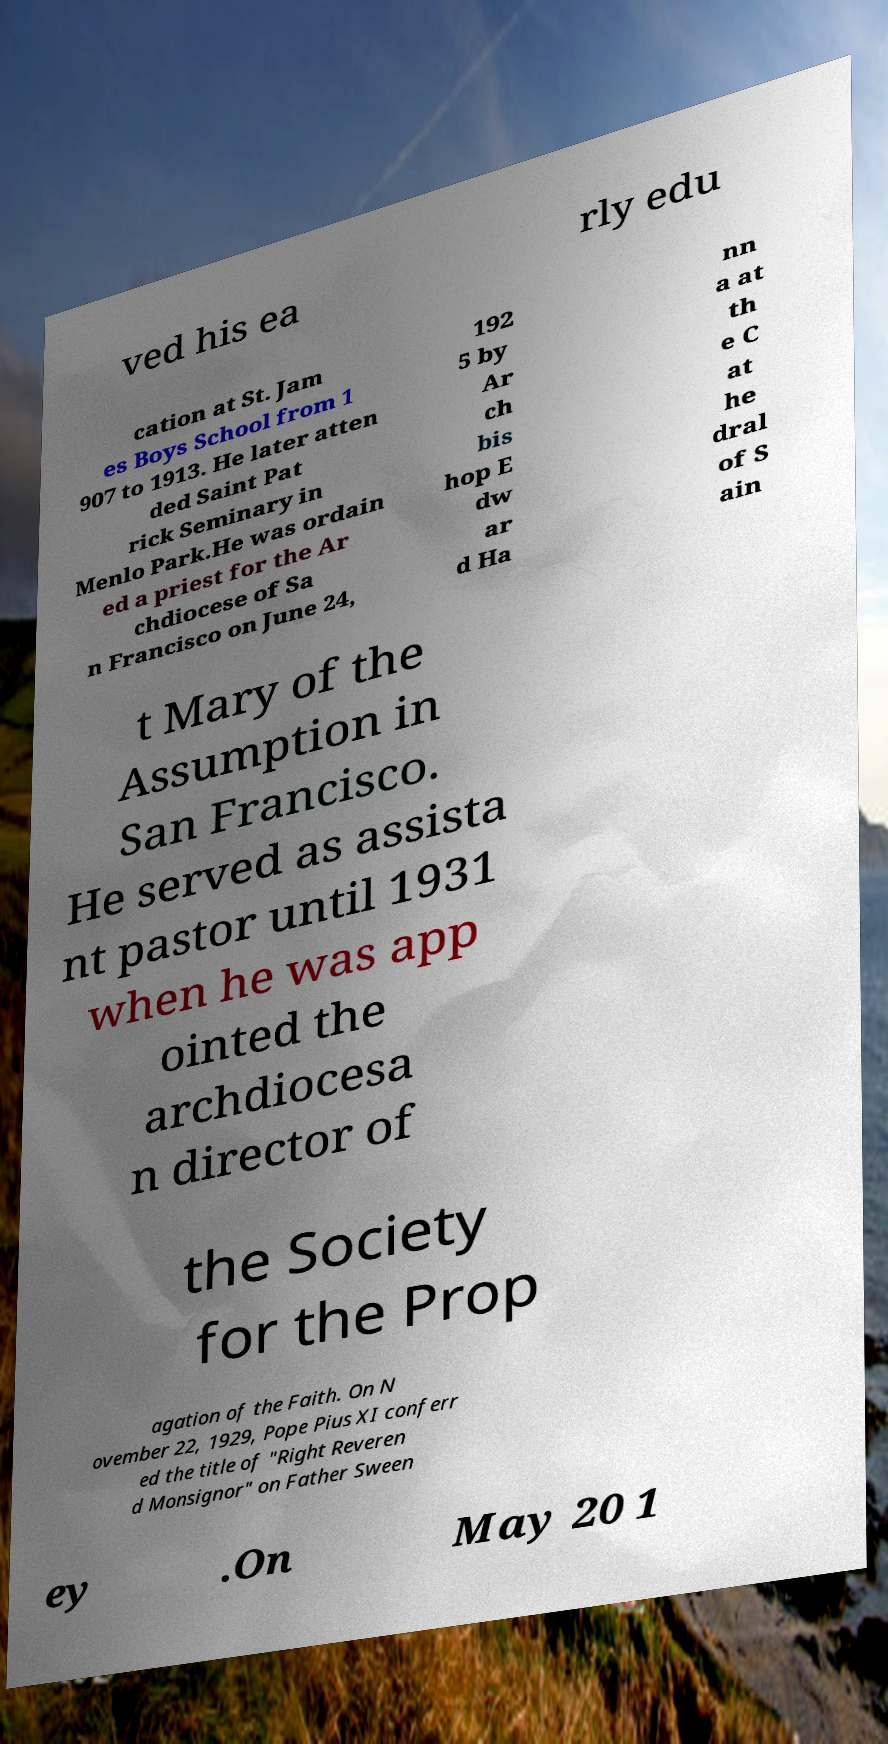Can you read and provide the text displayed in the image?This photo seems to have some interesting text. Can you extract and type it out for me? ved his ea rly edu cation at St. Jam es Boys School from 1 907 to 1913. He later atten ded Saint Pat rick Seminary in Menlo Park.He was ordain ed a priest for the Ar chdiocese of Sa n Francisco on June 24, 192 5 by Ar ch bis hop E dw ar d Ha nn a at th e C at he dral of S ain t Mary of the Assumption in San Francisco. He served as assista nt pastor until 1931 when he was app ointed the archdiocesa n director of the Society for the Prop agation of the Faith. On N ovember 22, 1929, Pope Pius XI conferr ed the title of "Right Reveren d Monsignor" on Father Sween ey .On May 20 1 